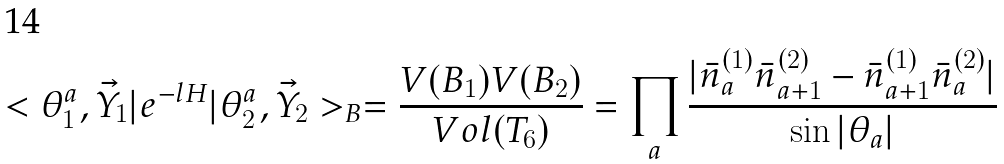<formula> <loc_0><loc_0><loc_500><loc_500>< \theta _ { 1 } ^ { a } , \vec { Y } _ { 1 } | e ^ { - l H } | \theta _ { 2 } ^ { a } , \vec { Y } _ { 2 } > _ { B } = \frac { V ( B _ { 1 } ) V ( B _ { 2 } ) } { V o l ( T _ { 6 } ) } = \prod _ { a } \frac { | \bar { n } _ { a } ^ { ( 1 ) } \bar { n } _ { a + 1 } ^ { ( 2 ) } - \bar { n } _ { a + 1 } ^ { ( 1 ) } \bar { n } _ { a } ^ { ( 2 ) } | } { \sin | \theta _ { a } | }</formula> 